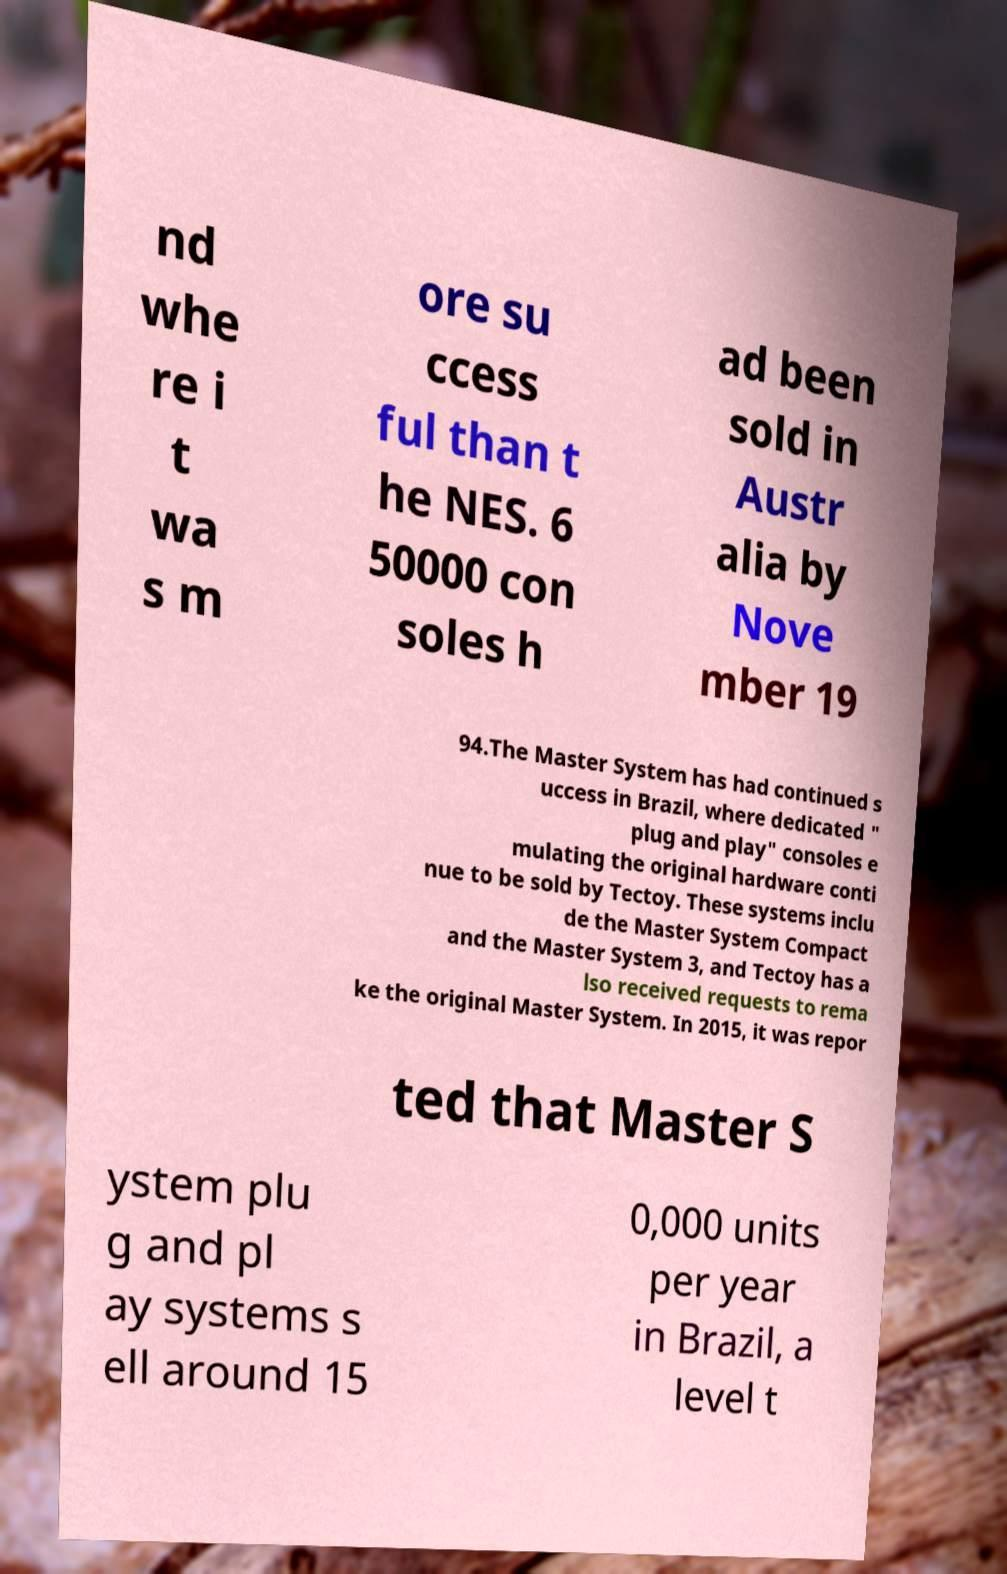For documentation purposes, I need the text within this image transcribed. Could you provide that? nd whe re i t wa s m ore su ccess ful than t he NES. 6 50000 con soles h ad been sold in Austr alia by Nove mber 19 94.The Master System has had continued s uccess in Brazil, where dedicated " plug and play" consoles e mulating the original hardware conti nue to be sold by Tectoy. These systems inclu de the Master System Compact and the Master System 3, and Tectoy has a lso received requests to rema ke the original Master System. In 2015, it was repor ted that Master S ystem plu g and pl ay systems s ell around 15 0,000 units per year in Brazil, a level t 